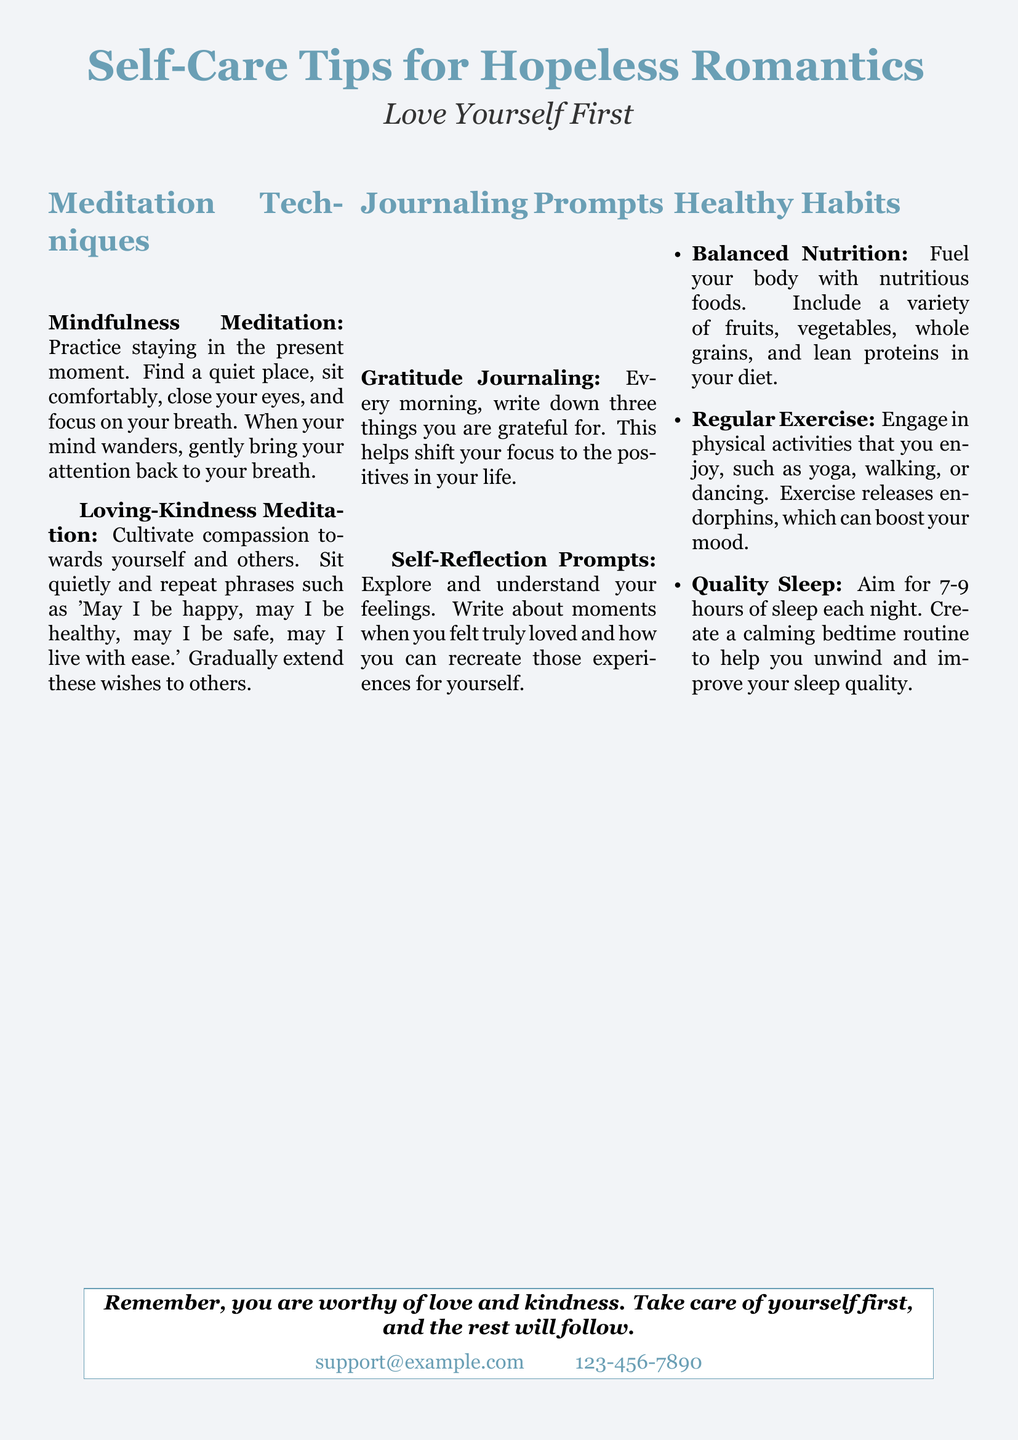What is the main title of the flyer? The title is prominently displayed at the top of the flyer.
Answer: Self-Care Tips for Hopeless Romantics What is the subtitle of the flyer? The subtitle provides an additional message related to the main title.
Answer: Love Yourself First What meditation technique focuses on the present moment? The document lists specific meditation techniques, one of which is about staying present.
Answer: Mindfulness Meditation How many journaling prompts are mentioned in the flyer? The flyer lists two specific types of journaling prompts.
Answer: Two What is one recommended healthy habit related to sleep? The flyer suggests certain habits for self-care, including a point about sleep quality.
Answer: Quality Sleep Which meditation technique encourages compassion? Among the meditation techniques, one specifically cultivates compassion.
Answer: Loving-Kindness Meditation What should you write in the gratitude journaling? The journaling prompt instructs you to focus on certain positive aspects each day.
Answer: Three things you are grateful for What is a suggested form of exercise mentioned in the flyer? The flyer lists various enjoyable physical activities under healthy habits.
Answer: Yoga What contact information is provided on the flyer? The flyer includes a specific section for contact information at the bottom.
Answer: support@example.com 123-456-7890 